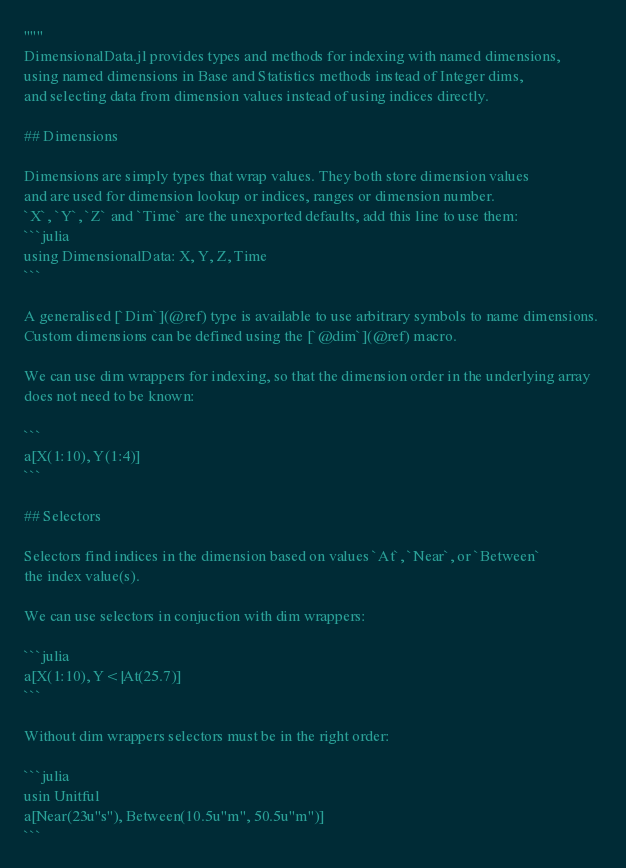Convert code to text. <code><loc_0><loc_0><loc_500><loc_500><_Julia_>"""
DimensionalData.jl provides types and methods for indexing with named dimensions,
using named dimensions in Base and Statistics methods instead of Integer dims,
and selecting data from dimension values instead of using indices directly.

## Dimensions

Dimensions are simply types that wrap values. They both store dimension values
and are used for dimension lookup or indices, ranges or dimension number.
`X`, `Y`, `Z` and `Time` are the unexported defaults, add this line to use them:  
```julia
using DimensionalData: X, Y, Z, Time
```

A generalised [`Dim`](@ref) type is available to use arbitrary symbols to name dimensions. 
Custom dimensions can be defined using the [`@dim`](@ref) macro.

We can use dim wrappers for indexing, so that the dimension order in the underlying array 
does not need to be known:

```
a[X(1:10), Y(1:4)]
```

## Selectors

Selectors find indices in the dimension based on values `At`, `Near`, or `Between`
the index value(s).

We can use selectors in conjuction with dim wrappers:

```julia
a[X(1:10), Y<|At(25.7)]
```

Without dim wrappers selectors must be in the right order:

```julia
usin Unitful
a[Near(23u"s"), Between(10.5u"m", 50.5u"m")]
```
</code> 